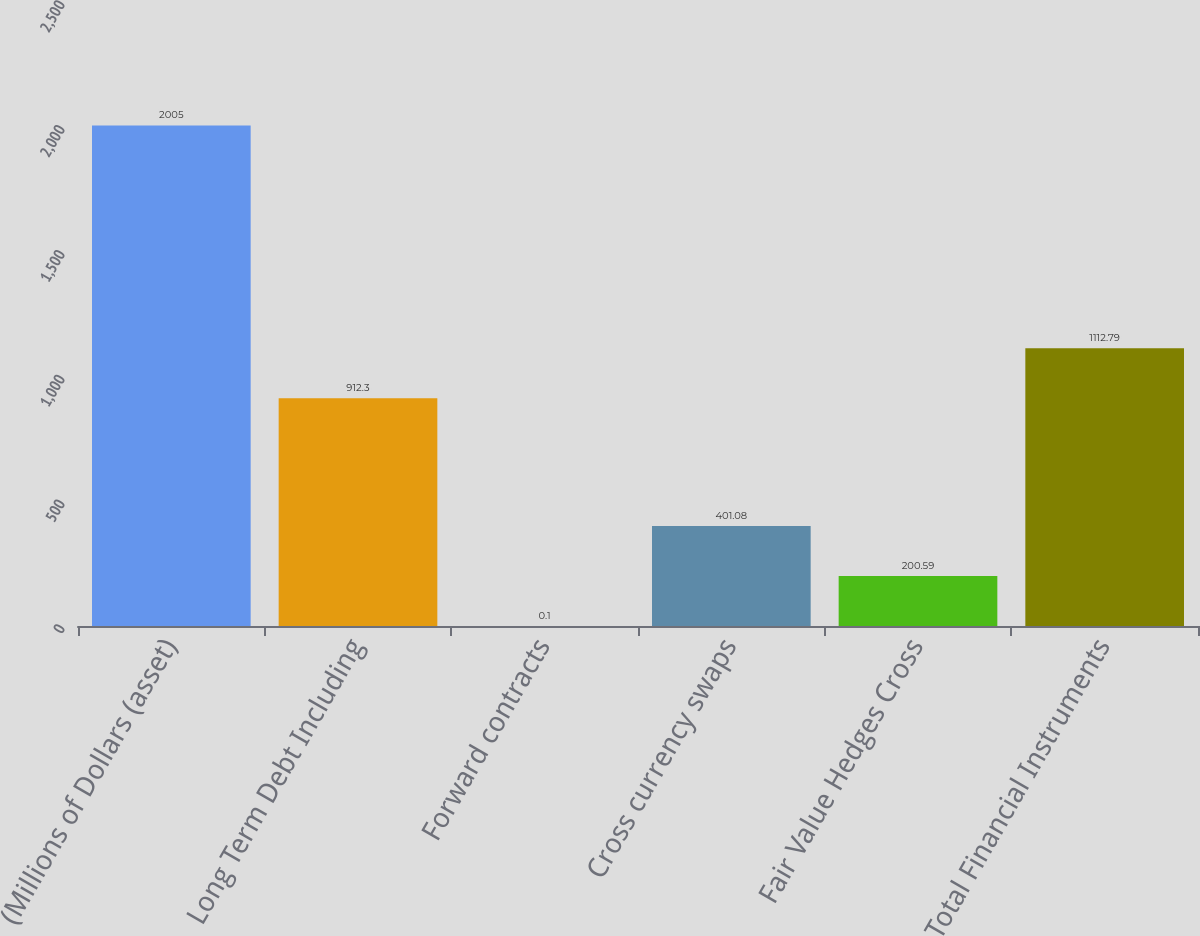Convert chart to OTSL. <chart><loc_0><loc_0><loc_500><loc_500><bar_chart><fcel>(Millions of Dollars (asset)<fcel>Long Term Debt Including<fcel>Forward contracts<fcel>Cross currency swaps<fcel>Fair Value Hedges Cross<fcel>Total Financial Instruments<nl><fcel>2005<fcel>912.3<fcel>0.1<fcel>401.08<fcel>200.59<fcel>1112.79<nl></chart> 